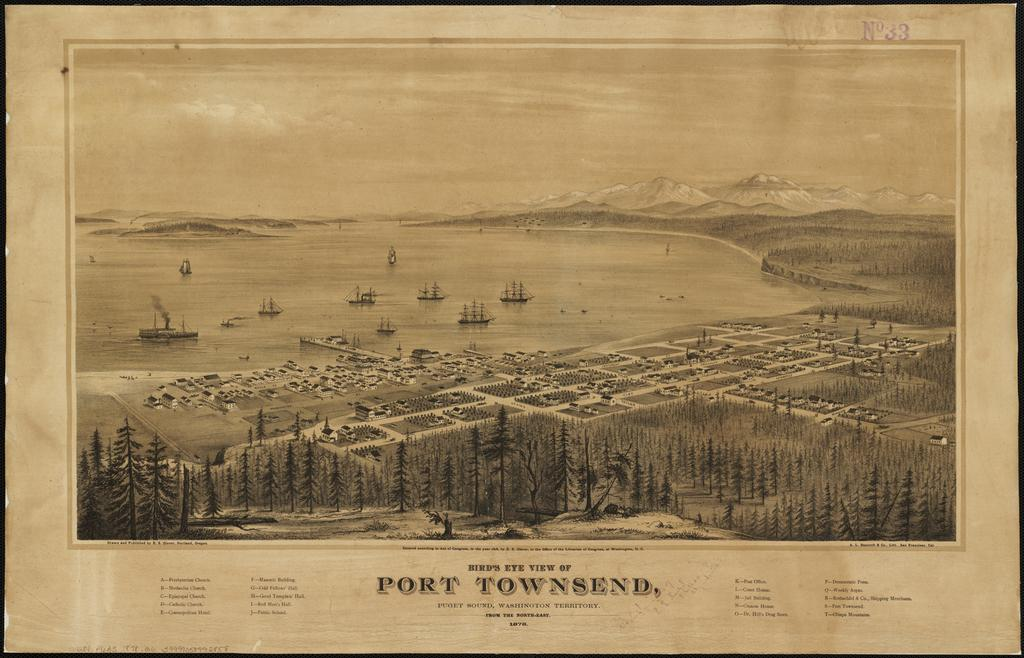<image>
Present a compact description of the photo's key features. the word port is on the front of a piece of paper 